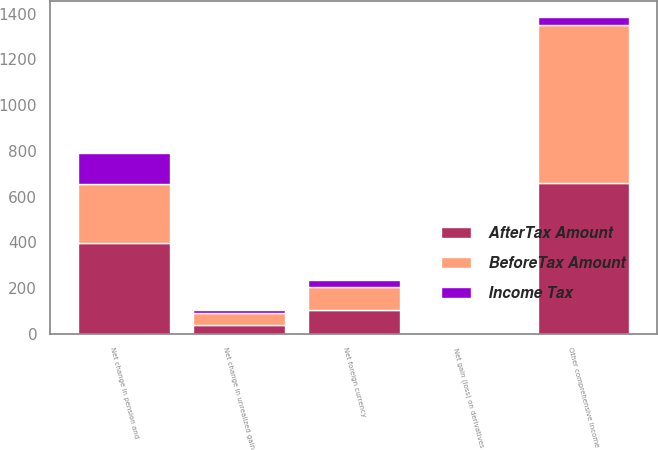Convert chart to OTSL. <chart><loc_0><loc_0><loc_500><loc_500><stacked_bar_chart><ecel><fcel>Net foreign currency<fcel>Net gain (loss) on derivatives<fcel>Net change in unrealized gain<fcel>Net change in pension and<fcel>Other comprehensive income<nl><fcel>AfterTax Amount<fcel>102<fcel>2<fcel>39<fcel>396<fcel>659<nl><fcel>Income Tax<fcel>31<fcel>1<fcel>13<fcel>136<fcel>34<nl><fcel>BeforeTax Amount<fcel>102<fcel>1<fcel>52<fcel>260<fcel>693<nl></chart> 